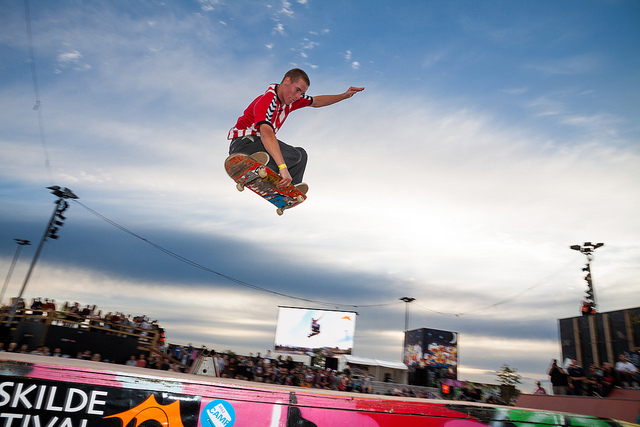What skills are necessary for performing a skateboarding trick like the one in the image? Performing a skateboarding trick like the one in the image requires several skills: excellent balance and coordination, the ability to time jumps correctly, good control of the skateboard for grabs, and the courage to perform aerial stunts. It also requires practice, muscle memory, and an understanding of how to land safely without injury. What might the man be feeling as he performs the trick? As the man performs the trick, he might be feeling a rush of adrenaline and excitement. There could be a sense of focus and concentration, as landing such tricks requires precision and skill. He might also feel a sense of accomplishment and thrill, especially if he's aware of the crowd watching and cheering him on. 